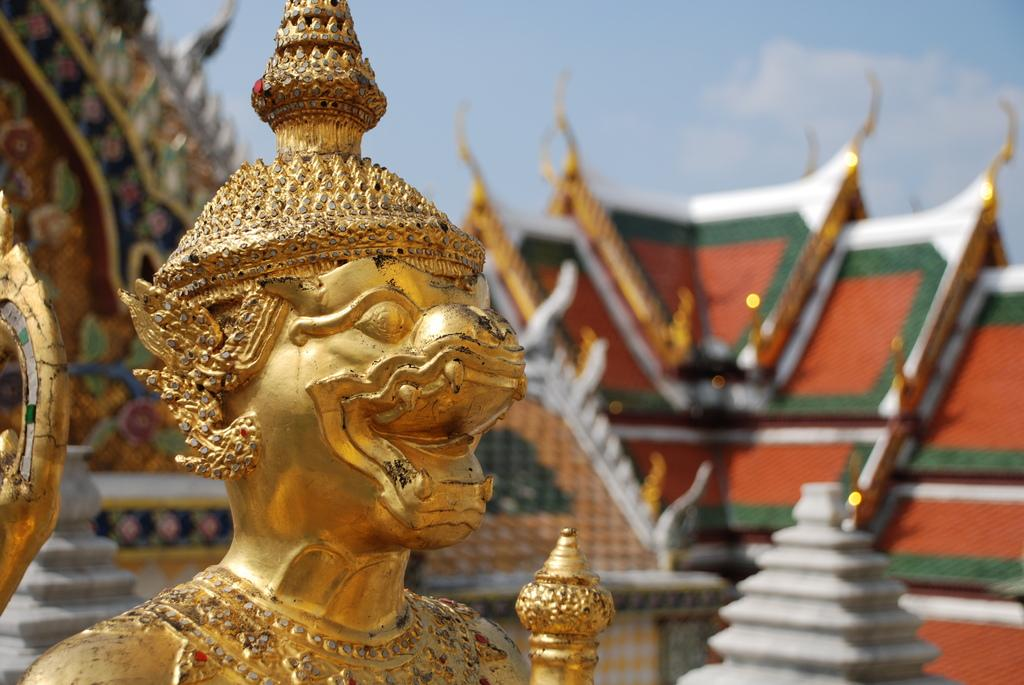What is the main subject of the image? There is a gold statue in the image. What can be seen in the background of the image? There is a roof top and the sky visible in the background of the image. What type of leather is used to cover the appliance in the image? There is no appliance or leather present in the image; it features a gold statue and a background with a roof top and the sky. 